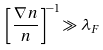Convert formula to latex. <formula><loc_0><loc_0><loc_500><loc_500>\left [ \frac { \nabla n } { n } \right ] ^ { - 1 } \gg \lambda _ { F }</formula> 